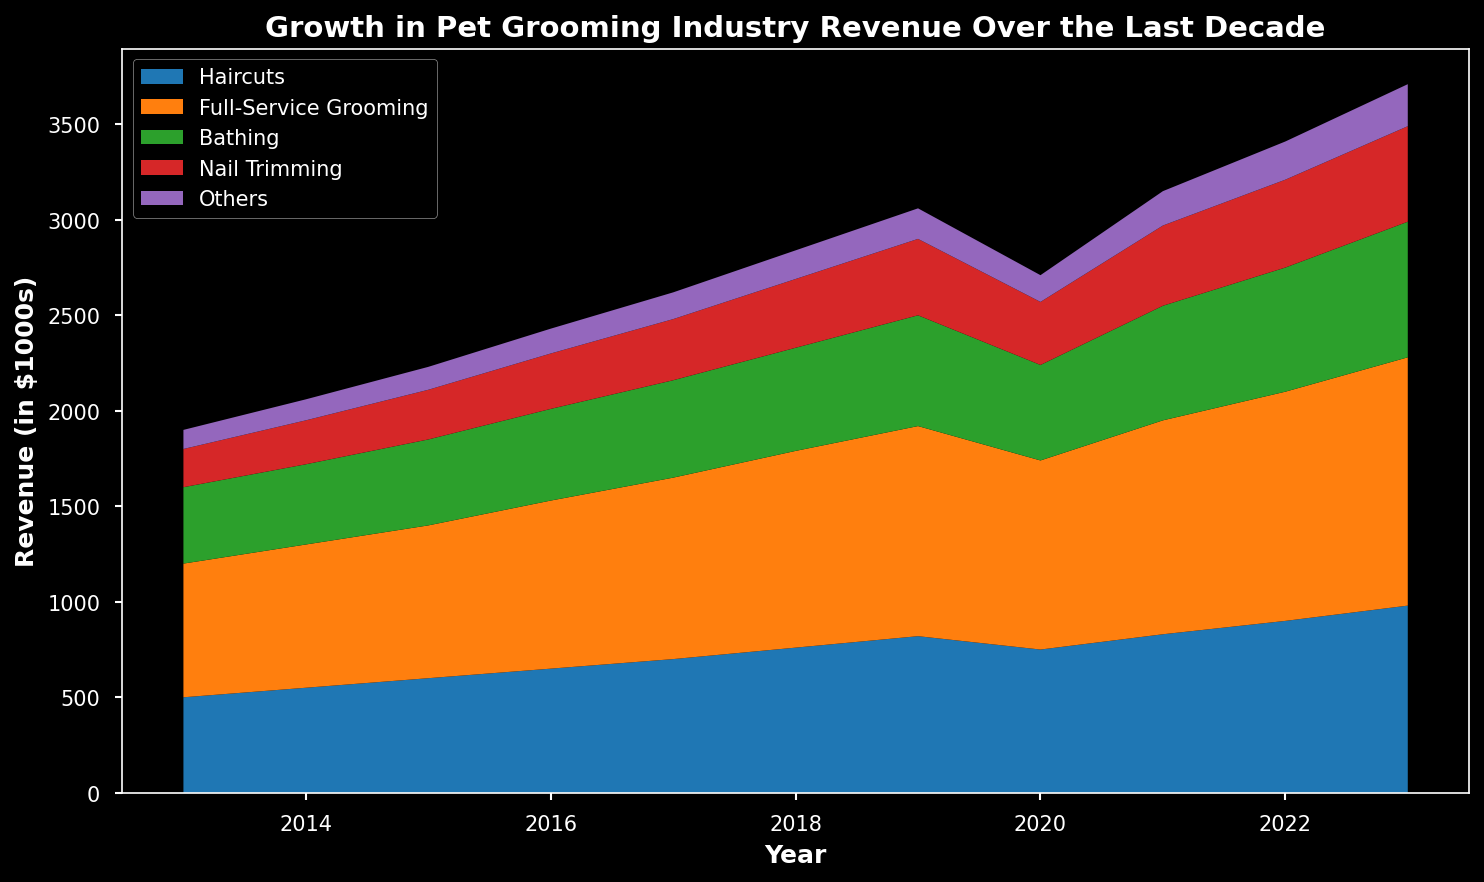What's the trend of Full-Service Grooming revenue over the last decade? Full-Service Grooming revenue has steadily increased from 2013 to 2023, with a slight dip in 2020.
Answer: Steady increase with a slight dip in 2020 Which year saw the highest total revenue from all services combined? To find the highest total revenue, sum the revenue for each service type for each year and identify the year with the highest total. The highest combined revenue is in 2023.
Answer: 2023 How does the revenue from Haircuts in 2023 compare to the revenue from Nail Trimming in 2020? In 2023, the revenue from Haircuts was $980k, whereas in 2020, the revenue from Nail Trimming was $330k. By comparing, Haircuts' revenue in 2023 was significantly higher.
Answer: Haircuts' revenue in 2023 was significantly higher What is the overall revenue growth for Bathing from 2013 to 2023? In 2013, Bathing revenue was $400k; in 2023, it was $710k. The growth over this period is $710k - $400k = $310k.
Answer: $310k Which service had the most consistent revenue growth over the decade? By observing the visual trend lines, Full-Service Grooming had the most consistent and steady growth without any major dips, except for a slight decline in 2020.
Answer: Full-Service Grooming What is the total revenue from Others in the years 2017 to 2019? Sum the revenues of Others for the years 2017, 2018, and 2019: $140k + $150k + $160k = $450k.
Answer: $450k Which service type experienced a decrease in revenue in any given year, and in which year did this occur? Haircuts experienced a revenue decrease in 2020, falling from $820k in 2019 to $750k in 2020.
Answer: Haircuts in 2020 In which year did Nail Trimming begin to experience more noticeable revenue growth? Nail Trimming revenue began a noticeable growth trend starting in 2017 and continued upwards from there.
Answer: 2017 How does the combined revenue of Haircuts and Bathing in 2023 compare to the combined revenue of Full-Service Grooming and Nail Trimming in 2023? In 2023, revenue from Haircuts was $980k and Bathing was $710k, totaling $1690k. Full-Service Grooming was $1300k and Nail Trimming was $500k, totaling $1800k. Compare: $1690k vs $1800k.
Answer: Full-Service Grooming and Nail Trimming revenue in 2023 was higher What was the percentage increase in revenue for Full-Service Grooming between 2013 and 2023? Revenue for Full-Service Grooming in 2013 was $700k and in 2023 was $1300k. The percentage increase is ((1300k - 700k) / 700k) * 100% = approximately 85.71%.
Answer: 85.71% 